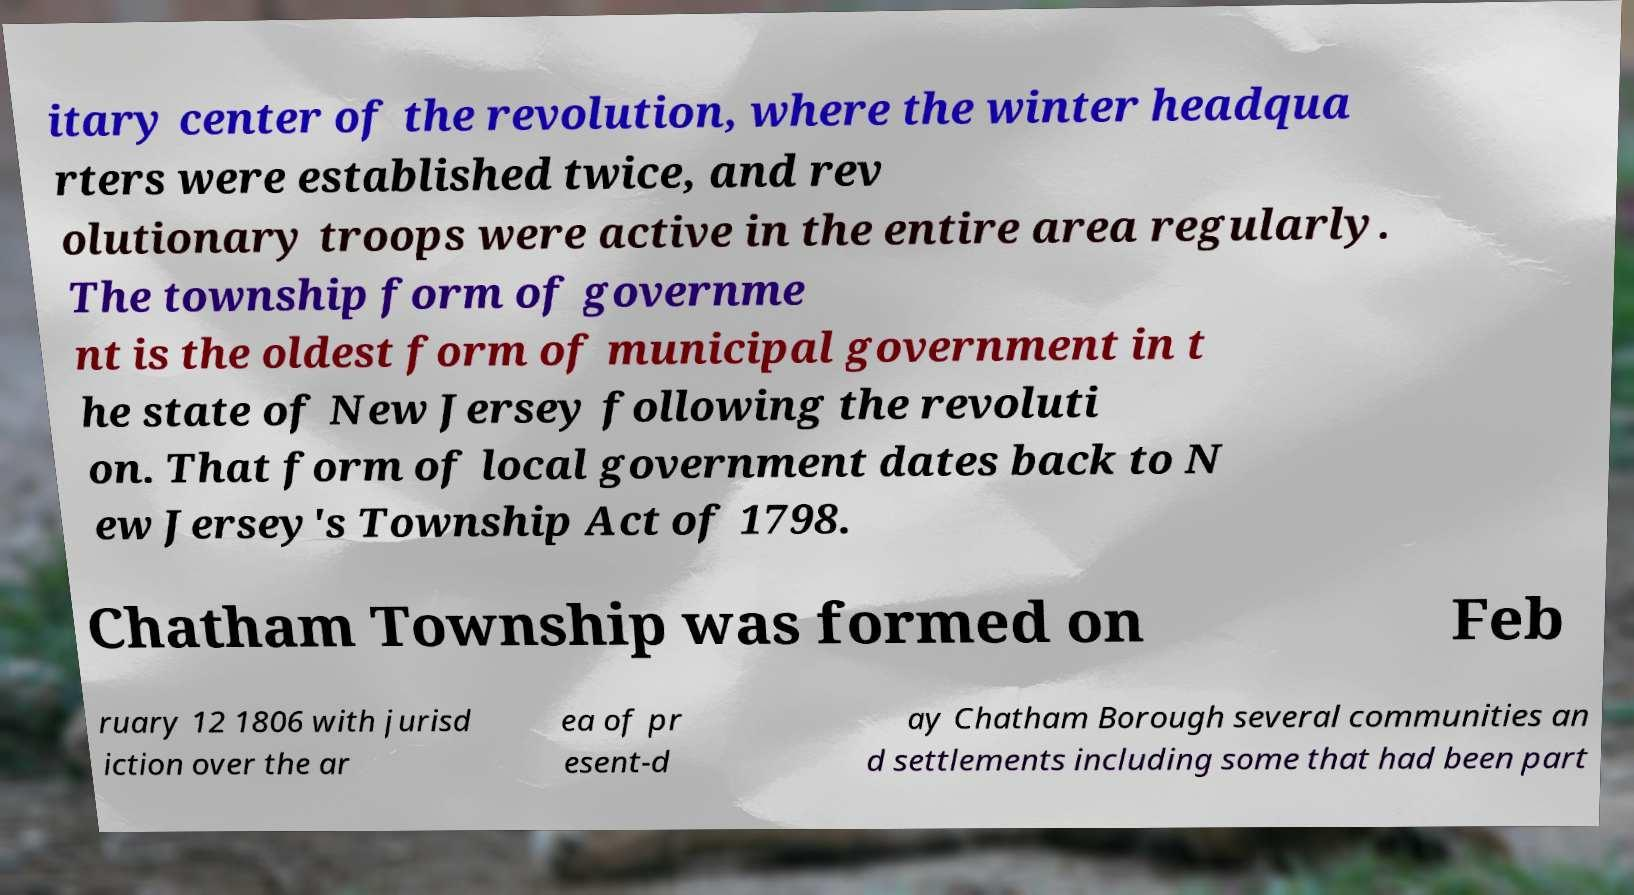I need the written content from this picture converted into text. Can you do that? itary center of the revolution, where the winter headqua rters were established twice, and rev olutionary troops were active in the entire area regularly. The township form of governme nt is the oldest form of municipal government in t he state of New Jersey following the revoluti on. That form of local government dates back to N ew Jersey's Township Act of 1798. Chatham Township was formed on Feb ruary 12 1806 with jurisd iction over the ar ea of pr esent-d ay Chatham Borough several communities an d settlements including some that had been part 